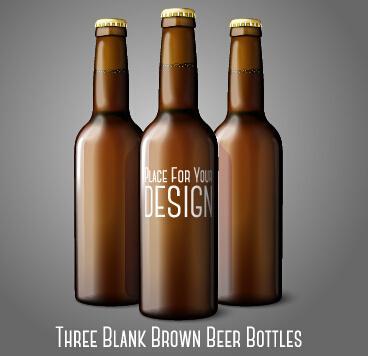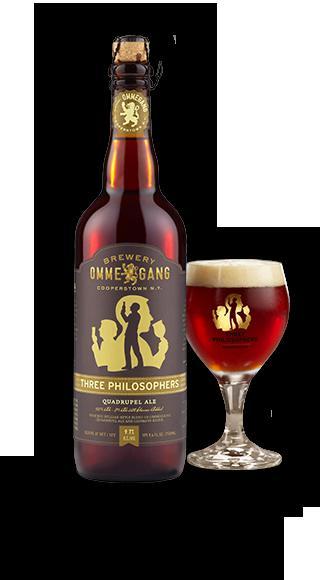The first image is the image on the left, the second image is the image on the right. For the images displayed, is the sentence "All bottles are shown in groups of three and are capped." factually correct? Answer yes or no. No. The first image is the image on the left, the second image is the image on the right. Examine the images to the left and right. Is the description "One set of bottles is yellow and the other set is more brown." accurate? Answer yes or no. No. 